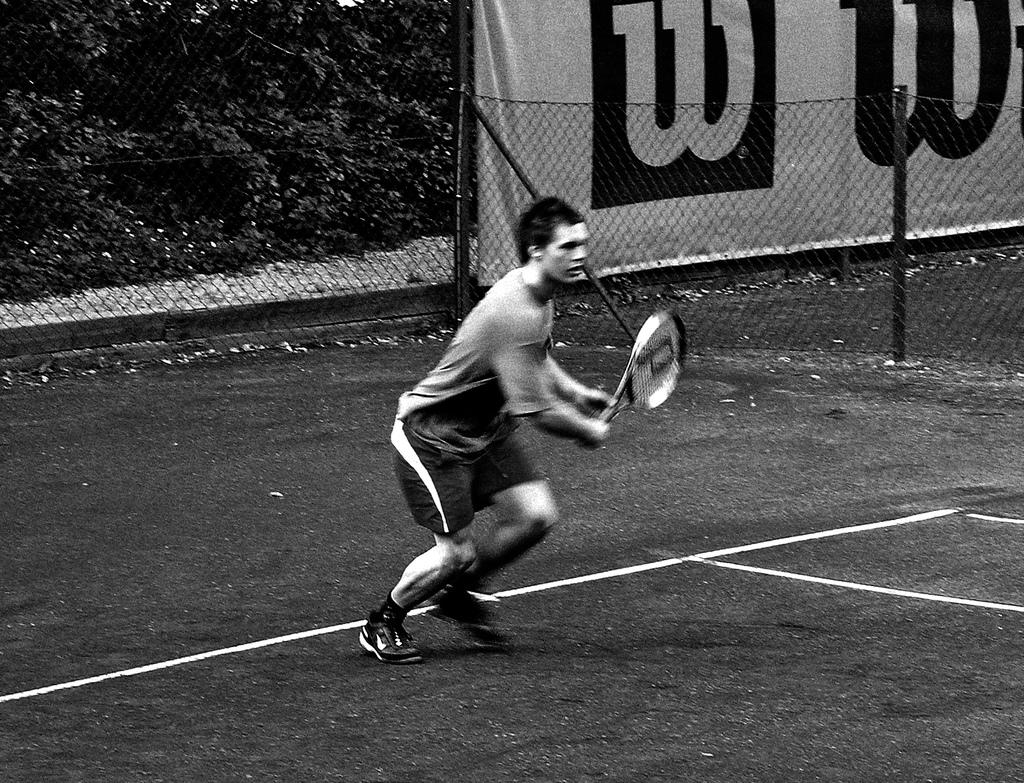What is the man in the image holding? The man is holding a bat in the image. What can be seen in the background of the image? There are trees in the image. What is the man standing near in the image? There is fencing in the image. Where is the faucet located in the image? There is no faucet present in the image. 